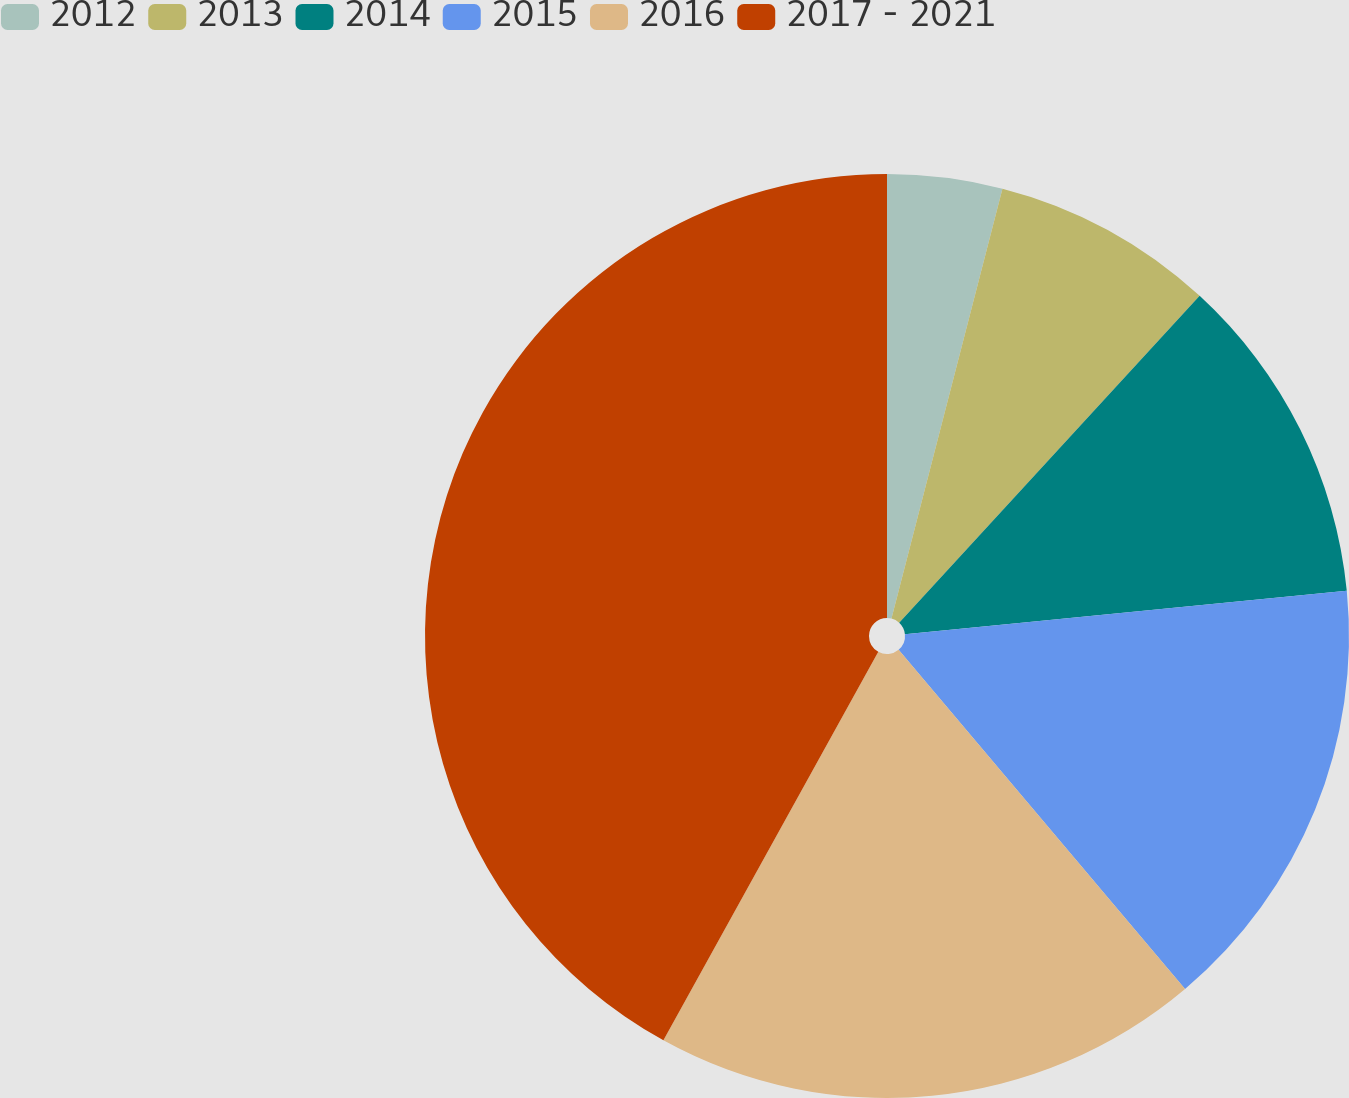Convert chart. <chart><loc_0><loc_0><loc_500><loc_500><pie_chart><fcel>2012<fcel>2013<fcel>2014<fcel>2015<fcel>2016<fcel>2017 - 2021<nl><fcel>4.02%<fcel>7.81%<fcel>11.61%<fcel>15.4%<fcel>19.2%<fcel>41.96%<nl></chart> 